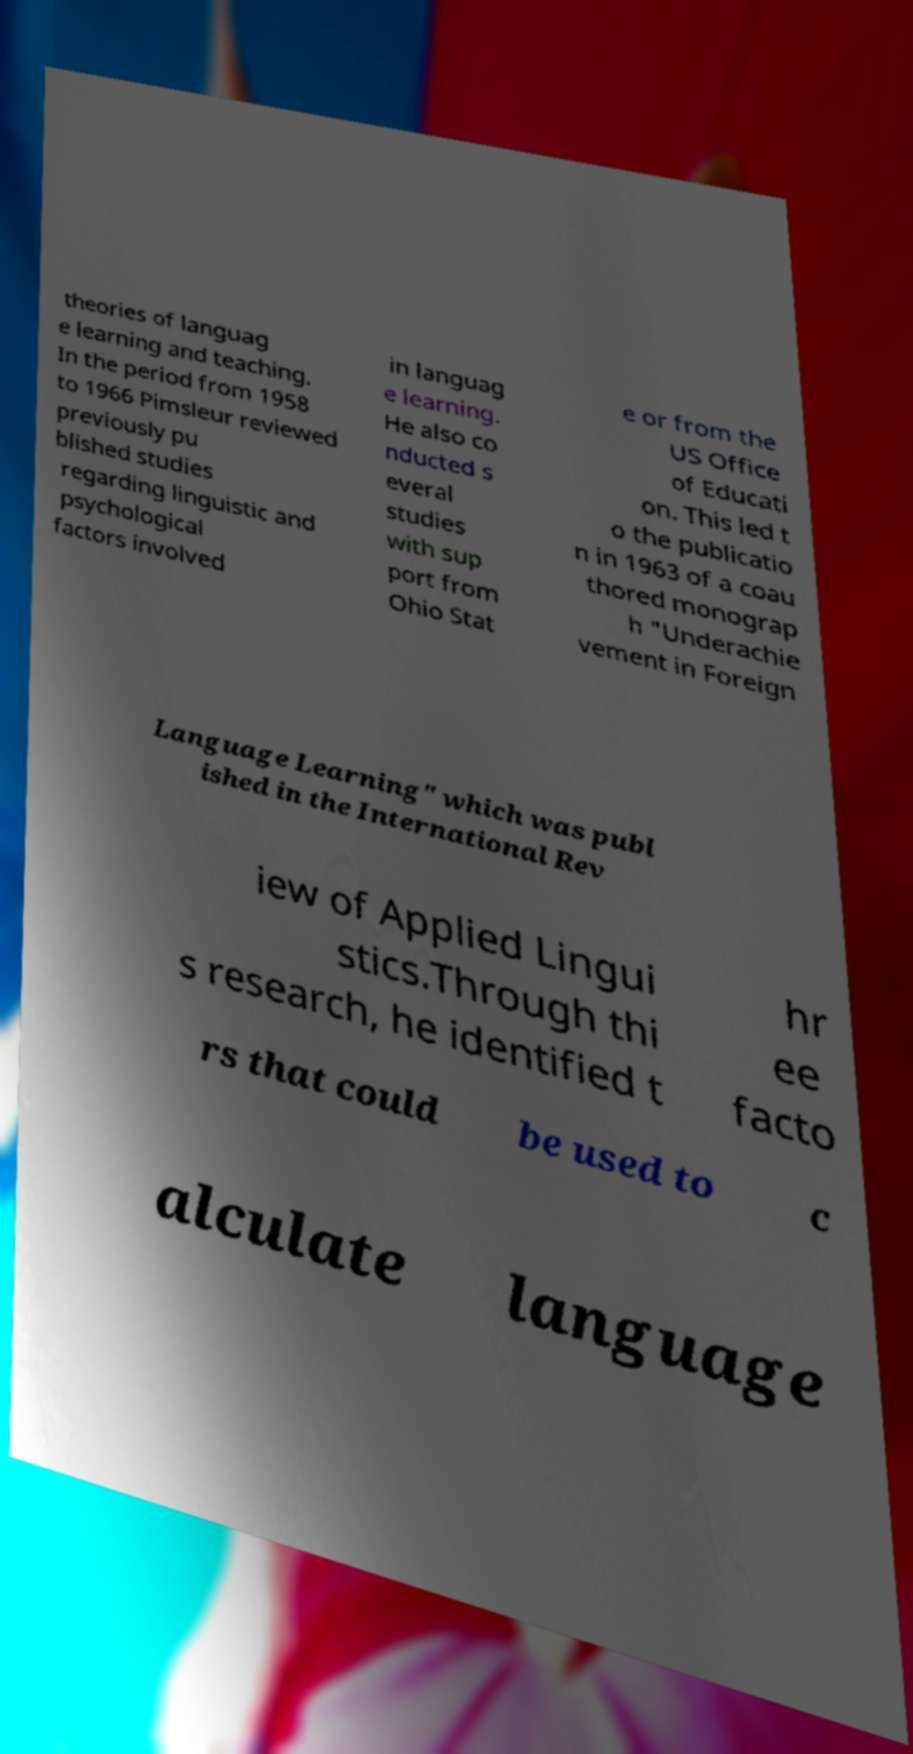Can you read and provide the text displayed in the image?This photo seems to have some interesting text. Can you extract and type it out for me? theories of languag e learning and teaching. In the period from 1958 to 1966 Pimsleur reviewed previously pu blished studies regarding linguistic and psychological factors involved in languag e learning. He also co nducted s everal studies with sup port from Ohio Stat e or from the US Office of Educati on. This led t o the publicatio n in 1963 of a coau thored monograp h "Underachie vement in Foreign Language Learning" which was publ ished in the International Rev iew of Applied Lingui stics.Through thi s research, he identified t hr ee facto rs that could be used to c alculate language 